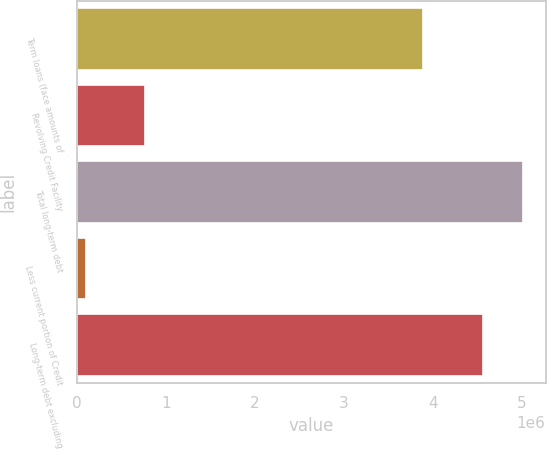Convert chart to OTSL. <chart><loc_0><loc_0><loc_500><loc_500><bar_chart><fcel>Term loans (face amounts of<fcel>Revolving Credit Facility<fcel>Total long-term debt<fcel>Less current portion of Credit<fcel>Long-term debt excluding<nl><fcel>3.89472e+06<fcel>765000<fcel>5.01535e+06<fcel>100308<fcel>4.55941e+06<nl></chart> 